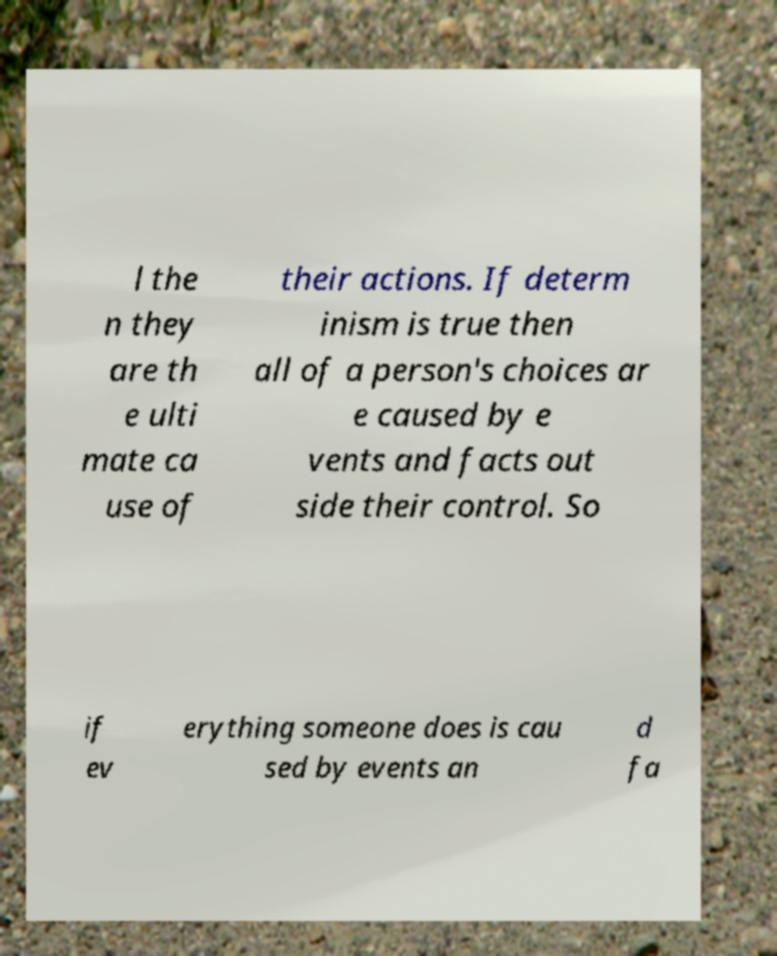What messages or text are displayed in this image? I need them in a readable, typed format. l the n they are th e ulti mate ca use of their actions. If determ inism is true then all of a person's choices ar e caused by e vents and facts out side their control. So if ev erything someone does is cau sed by events an d fa 